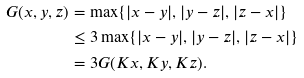Convert formula to latex. <formula><loc_0><loc_0><loc_500><loc_500>G ( x , y , z ) & = \max \{ | x - y | , | y - z | , | z - x | \} \\ & \leq 3 \max \{ | x - y | , | y - z | , | z - x | \} \\ & = 3 G ( K x , K y , K z ) .</formula> 